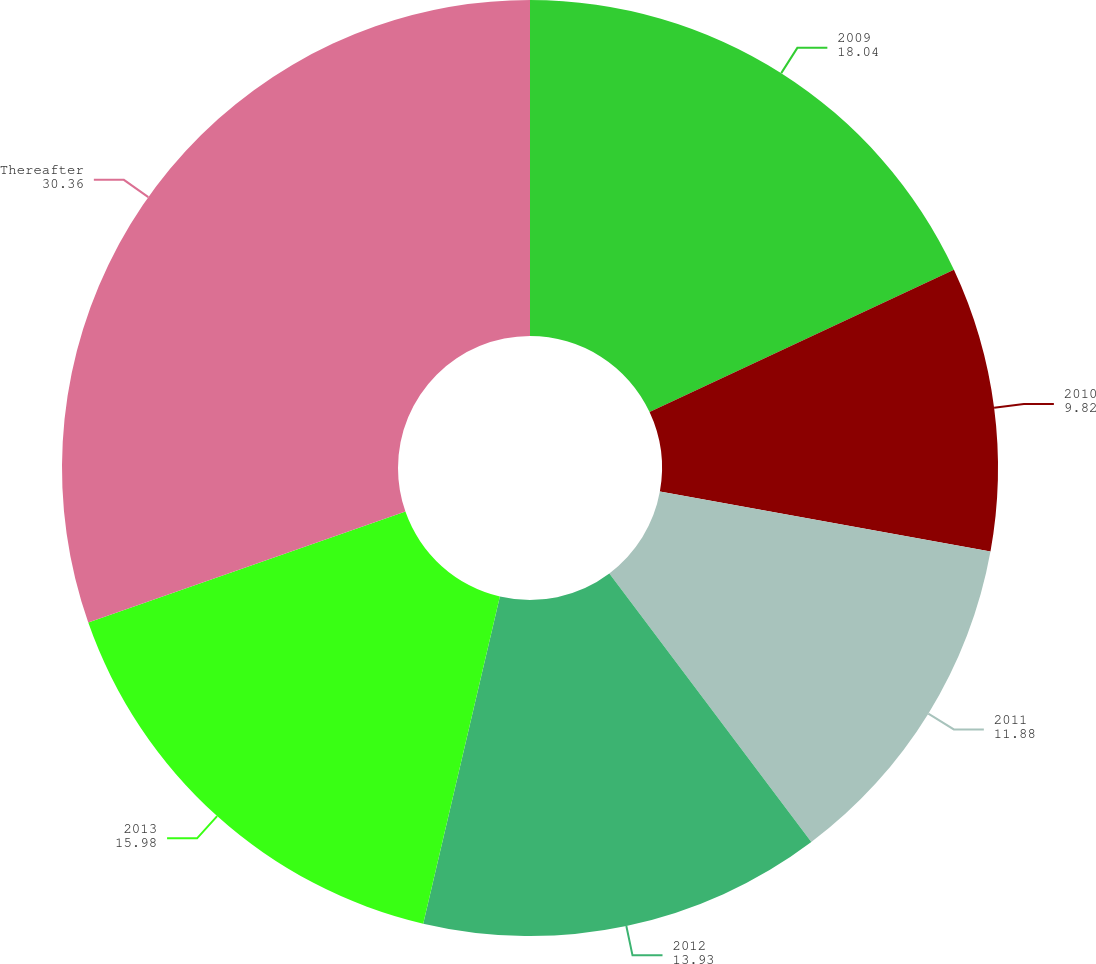<chart> <loc_0><loc_0><loc_500><loc_500><pie_chart><fcel>2009<fcel>2010<fcel>2011<fcel>2012<fcel>2013<fcel>Thereafter<nl><fcel>18.04%<fcel>9.82%<fcel>11.88%<fcel>13.93%<fcel>15.98%<fcel>30.36%<nl></chart> 